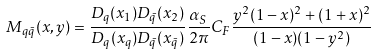<formula> <loc_0><loc_0><loc_500><loc_500>M _ { q \bar { q } } ( x , y ) = \frac { D _ { q } ( x _ { 1 } ) D _ { \bar { q } } ( x _ { 2 } ) } { D _ { q } ( x _ { q } ) D _ { \bar { q } } ( x _ { \bar { q } } ) } \frac { \alpha _ { S } } { 2 \pi } C _ { F } \frac { y ^ { 2 } ( 1 - x ) ^ { 2 } + ( 1 + x ) ^ { 2 } } { ( 1 - x ) ( 1 - y ^ { 2 } ) }</formula> 